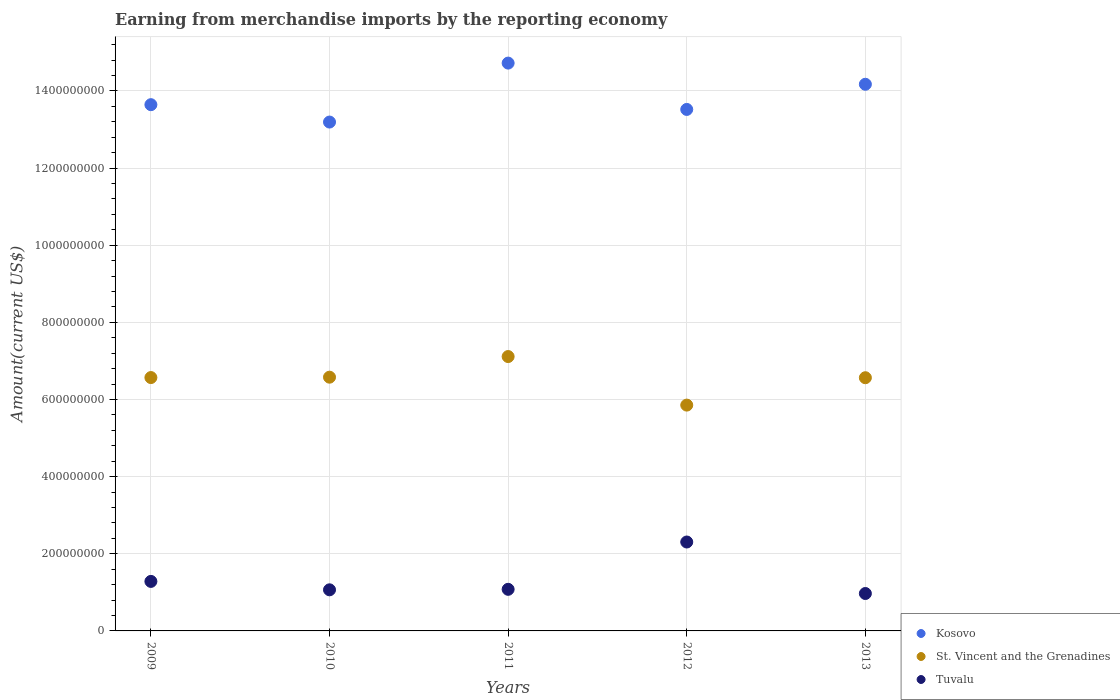What is the amount earned from merchandise imports in St. Vincent and the Grenadines in 2009?
Keep it short and to the point. 6.57e+08. Across all years, what is the maximum amount earned from merchandise imports in Tuvalu?
Your response must be concise. 2.31e+08. Across all years, what is the minimum amount earned from merchandise imports in St. Vincent and the Grenadines?
Offer a terse response. 5.85e+08. What is the total amount earned from merchandise imports in St. Vincent and the Grenadines in the graph?
Give a very brief answer. 3.27e+09. What is the difference between the amount earned from merchandise imports in Kosovo in 2010 and that in 2013?
Offer a very short reply. -9.80e+07. What is the difference between the amount earned from merchandise imports in St. Vincent and the Grenadines in 2013 and the amount earned from merchandise imports in Kosovo in 2012?
Make the answer very short. -6.96e+08. What is the average amount earned from merchandise imports in Tuvalu per year?
Give a very brief answer. 1.34e+08. In the year 2012, what is the difference between the amount earned from merchandise imports in Kosovo and amount earned from merchandise imports in Tuvalu?
Provide a short and direct response. 1.12e+09. In how many years, is the amount earned from merchandise imports in Tuvalu greater than 1400000000 US$?
Your answer should be compact. 0. What is the ratio of the amount earned from merchandise imports in Tuvalu in 2009 to that in 2011?
Offer a terse response. 1.19. Is the amount earned from merchandise imports in Kosovo in 2010 less than that in 2011?
Ensure brevity in your answer.  Yes. What is the difference between the highest and the second highest amount earned from merchandise imports in St. Vincent and the Grenadines?
Give a very brief answer. 5.35e+07. What is the difference between the highest and the lowest amount earned from merchandise imports in St. Vincent and the Grenadines?
Your answer should be very brief. 1.26e+08. In how many years, is the amount earned from merchandise imports in Kosovo greater than the average amount earned from merchandise imports in Kosovo taken over all years?
Provide a succinct answer. 2. Is the amount earned from merchandise imports in St. Vincent and the Grenadines strictly greater than the amount earned from merchandise imports in Tuvalu over the years?
Ensure brevity in your answer.  Yes. Is the amount earned from merchandise imports in Kosovo strictly less than the amount earned from merchandise imports in Tuvalu over the years?
Your answer should be very brief. No. How many dotlines are there?
Your answer should be very brief. 3. What is the difference between two consecutive major ticks on the Y-axis?
Your answer should be compact. 2.00e+08. Are the values on the major ticks of Y-axis written in scientific E-notation?
Offer a very short reply. No. Where does the legend appear in the graph?
Provide a short and direct response. Bottom right. How many legend labels are there?
Provide a short and direct response. 3. How are the legend labels stacked?
Your answer should be very brief. Vertical. What is the title of the graph?
Keep it short and to the point. Earning from merchandise imports by the reporting economy. What is the label or title of the X-axis?
Provide a succinct answer. Years. What is the label or title of the Y-axis?
Provide a short and direct response. Amount(current US$). What is the Amount(current US$) in Kosovo in 2009?
Provide a short and direct response. 1.36e+09. What is the Amount(current US$) in St. Vincent and the Grenadines in 2009?
Your answer should be compact. 6.57e+08. What is the Amount(current US$) in Tuvalu in 2009?
Ensure brevity in your answer.  1.28e+08. What is the Amount(current US$) in Kosovo in 2010?
Your answer should be very brief. 1.32e+09. What is the Amount(current US$) in St. Vincent and the Grenadines in 2010?
Your answer should be very brief. 6.58e+08. What is the Amount(current US$) in Tuvalu in 2010?
Your response must be concise. 1.07e+08. What is the Amount(current US$) in Kosovo in 2011?
Offer a very short reply. 1.47e+09. What is the Amount(current US$) of St. Vincent and the Grenadines in 2011?
Make the answer very short. 7.11e+08. What is the Amount(current US$) in Tuvalu in 2011?
Your answer should be compact. 1.08e+08. What is the Amount(current US$) of Kosovo in 2012?
Keep it short and to the point. 1.35e+09. What is the Amount(current US$) in St. Vincent and the Grenadines in 2012?
Your answer should be compact. 5.85e+08. What is the Amount(current US$) in Tuvalu in 2012?
Ensure brevity in your answer.  2.31e+08. What is the Amount(current US$) in Kosovo in 2013?
Offer a terse response. 1.42e+09. What is the Amount(current US$) in St. Vincent and the Grenadines in 2013?
Provide a short and direct response. 6.56e+08. What is the Amount(current US$) in Tuvalu in 2013?
Offer a terse response. 9.70e+07. Across all years, what is the maximum Amount(current US$) of Kosovo?
Your answer should be very brief. 1.47e+09. Across all years, what is the maximum Amount(current US$) in St. Vincent and the Grenadines?
Offer a terse response. 7.11e+08. Across all years, what is the maximum Amount(current US$) of Tuvalu?
Ensure brevity in your answer.  2.31e+08. Across all years, what is the minimum Amount(current US$) of Kosovo?
Provide a short and direct response. 1.32e+09. Across all years, what is the minimum Amount(current US$) in St. Vincent and the Grenadines?
Your answer should be compact. 5.85e+08. Across all years, what is the minimum Amount(current US$) of Tuvalu?
Offer a very short reply. 9.70e+07. What is the total Amount(current US$) of Kosovo in the graph?
Give a very brief answer. 6.92e+09. What is the total Amount(current US$) of St. Vincent and the Grenadines in the graph?
Ensure brevity in your answer.  3.27e+09. What is the total Amount(current US$) in Tuvalu in the graph?
Offer a very short reply. 6.70e+08. What is the difference between the Amount(current US$) in Kosovo in 2009 and that in 2010?
Your answer should be compact. 4.51e+07. What is the difference between the Amount(current US$) of St. Vincent and the Grenadines in 2009 and that in 2010?
Your answer should be very brief. -9.77e+05. What is the difference between the Amount(current US$) of Tuvalu in 2009 and that in 2010?
Make the answer very short. 2.18e+07. What is the difference between the Amount(current US$) of Kosovo in 2009 and that in 2011?
Offer a terse response. -1.08e+08. What is the difference between the Amount(current US$) of St. Vincent and the Grenadines in 2009 and that in 2011?
Your answer should be very brief. -5.45e+07. What is the difference between the Amount(current US$) of Tuvalu in 2009 and that in 2011?
Ensure brevity in your answer.  2.05e+07. What is the difference between the Amount(current US$) of Kosovo in 2009 and that in 2012?
Your response must be concise. 1.23e+07. What is the difference between the Amount(current US$) of St. Vincent and the Grenadines in 2009 and that in 2012?
Your answer should be very brief. 7.14e+07. What is the difference between the Amount(current US$) of Tuvalu in 2009 and that in 2012?
Offer a terse response. -1.02e+08. What is the difference between the Amount(current US$) of Kosovo in 2009 and that in 2013?
Provide a short and direct response. -5.29e+07. What is the difference between the Amount(current US$) in St. Vincent and the Grenadines in 2009 and that in 2013?
Your response must be concise. 4.21e+05. What is the difference between the Amount(current US$) of Tuvalu in 2009 and that in 2013?
Your answer should be compact. 3.14e+07. What is the difference between the Amount(current US$) of Kosovo in 2010 and that in 2011?
Your response must be concise. -1.53e+08. What is the difference between the Amount(current US$) of St. Vincent and the Grenadines in 2010 and that in 2011?
Ensure brevity in your answer.  -5.35e+07. What is the difference between the Amount(current US$) of Tuvalu in 2010 and that in 2011?
Offer a terse response. -1.28e+06. What is the difference between the Amount(current US$) in Kosovo in 2010 and that in 2012?
Your answer should be compact. -3.27e+07. What is the difference between the Amount(current US$) in St. Vincent and the Grenadines in 2010 and that in 2012?
Give a very brief answer. 7.24e+07. What is the difference between the Amount(current US$) in Tuvalu in 2010 and that in 2012?
Your answer should be compact. -1.24e+08. What is the difference between the Amount(current US$) in Kosovo in 2010 and that in 2013?
Offer a terse response. -9.80e+07. What is the difference between the Amount(current US$) of St. Vincent and the Grenadines in 2010 and that in 2013?
Ensure brevity in your answer.  1.40e+06. What is the difference between the Amount(current US$) in Tuvalu in 2010 and that in 2013?
Your response must be concise. 9.57e+06. What is the difference between the Amount(current US$) in Kosovo in 2011 and that in 2012?
Offer a very short reply. 1.20e+08. What is the difference between the Amount(current US$) of St. Vincent and the Grenadines in 2011 and that in 2012?
Ensure brevity in your answer.  1.26e+08. What is the difference between the Amount(current US$) in Tuvalu in 2011 and that in 2012?
Provide a succinct answer. -1.23e+08. What is the difference between the Amount(current US$) of Kosovo in 2011 and that in 2013?
Give a very brief answer. 5.49e+07. What is the difference between the Amount(current US$) in St. Vincent and the Grenadines in 2011 and that in 2013?
Make the answer very short. 5.49e+07. What is the difference between the Amount(current US$) of Tuvalu in 2011 and that in 2013?
Ensure brevity in your answer.  1.08e+07. What is the difference between the Amount(current US$) in Kosovo in 2012 and that in 2013?
Your answer should be compact. -6.52e+07. What is the difference between the Amount(current US$) in St. Vincent and the Grenadines in 2012 and that in 2013?
Provide a short and direct response. -7.10e+07. What is the difference between the Amount(current US$) of Tuvalu in 2012 and that in 2013?
Your response must be concise. 1.34e+08. What is the difference between the Amount(current US$) in Kosovo in 2009 and the Amount(current US$) in St. Vincent and the Grenadines in 2010?
Make the answer very short. 7.06e+08. What is the difference between the Amount(current US$) of Kosovo in 2009 and the Amount(current US$) of Tuvalu in 2010?
Offer a very short reply. 1.26e+09. What is the difference between the Amount(current US$) in St. Vincent and the Grenadines in 2009 and the Amount(current US$) in Tuvalu in 2010?
Offer a very short reply. 5.50e+08. What is the difference between the Amount(current US$) of Kosovo in 2009 and the Amount(current US$) of St. Vincent and the Grenadines in 2011?
Ensure brevity in your answer.  6.53e+08. What is the difference between the Amount(current US$) of Kosovo in 2009 and the Amount(current US$) of Tuvalu in 2011?
Provide a short and direct response. 1.26e+09. What is the difference between the Amount(current US$) in St. Vincent and the Grenadines in 2009 and the Amount(current US$) in Tuvalu in 2011?
Give a very brief answer. 5.49e+08. What is the difference between the Amount(current US$) in Kosovo in 2009 and the Amount(current US$) in St. Vincent and the Grenadines in 2012?
Ensure brevity in your answer.  7.79e+08. What is the difference between the Amount(current US$) in Kosovo in 2009 and the Amount(current US$) in Tuvalu in 2012?
Provide a succinct answer. 1.13e+09. What is the difference between the Amount(current US$) of St. Vincent and the Grenadines in 2009 and the Amount(current US$) of Tuvalu in 2012?
Your response must be concise. 4.26e+08. What is the difference between the Amount(current US$) of Kosovo in 2009 and the Amount(current US$) of St. Vincent and the Grenadines in 2013?
Offer a very short reply. 7.08e+08. What is the difference between the Amount(current US$) of Kosovo in 2009 and the Amount(current US$) of Tuvalu in 2013?
Provide a short and direct response. 1.27e+09. What is the difference between the Amount(current US$) of St. Vincent and the Grenadines in 2009 and the Amount(current US$) of Tuvalu in 2013?
Ensure brevity in your answer.  5.60e+08. What is the difference between the Amount(current US$) of Kosovo in 2010 and the Amount(current US$) of St. Vincent and the Grenadines in 2011?
Your answer should be compact. 6.08e+08. What is the difference between the Amount(current US$) of Kosovo in 2010 and the Amount(current US$) of Tuvalu in 2011?
Provide a succinct answer. 1.21e+09. What is the difference between the Amount(current US$) of St. Vincent and the Grenadines in 2010 and the Amount(current US$) of Tuvalu in 2011?
Keep it short and to the point. 5.50e+08. What is the difference between the Amount(current US$) in Kosovo in 2010 and the Amount(current US$) in St. Vincent and the Grenadines in 2012?
Make the answer very short. 7.34e+08. What is the difference between the Amount(current US$) of Kosovo in 2010 and the Amount(current US$) of Tuvalu in 2012?
Give a very brief answer. 1.09e+09. What is the difference between the Amount(current US$) of St. Vincent and the Grenadines in 2010 and the Amount(current US$) of Tuvalu in 2012?
Make the answer very short. 4.27e+08. What is the difference between the Amount(current US$) of Kosovo in 2010 and the Amount(current US$) of St. Vincent and the Grenadines in 2013?
Your response must be concise. 6.63e+08. What is the difference between the Amount(current US$) in Kosovo in 2010 and the Amount(current US$) in Tuvalu in 2013?
Ensure brevity in your answer.  1.22e+09. What is the difference between the Amount(current US$) in St. Vincent and the Grenadines in 2010 and the Amount(current US$) in Tuvalu in 2013?
Your answer should be compact. 5.61e+08. What is the difference between the Amount(current US$) in Kosovo in 2011 and the Amount(current US$) in St. Vincent and the Grenadines in 2012?
Your response must be concise. 8.87e+08. What is the difference between the Amount(current US$) in Kosovo in 2011 and the Amount(current US$) in Tuvalu in 2012?
Give a very brief answer. 1.24e+09. What is the difference between the Amount(current US$) of St. Vincent and the Grenadines in 2011 and the Amount(current US$) of Tuvalu in 2012?
Offer a very short reply. 4.81e+08. What is the difference between the Amount(current US$) in Kosovo in 2011 and the Amount(current US$) in St. Vincent and the Grenadines in 2013?
Keep it short and to the point. 8.16e+08. What is the difference between the Amount(current US$) in Kosovo in 2011 and the Amount(current US$) in Tuvalu in 2013?
Your answer should be very brief. 1.38e+09. What is the difference between the Amount(current US$) of St. Vincent and the Grenadines in 2011 and the Amount(current US$) of Tuvalu in 2013?
Your response must be concise. 6.14e+08. What is the difference between the Amount(current US$) in Kosovo in 2012 and the Amount(current US$) in St. Vincent and the Grenadines in 2013?
Offer a very short reply. 6.96e+08. What is the difference between the Amount(current US$) of Kosovo in 2012 and the Amount(current US$) of Tuvalu in 2013?
Offer a very short reply. 1.26e+09. What is the difference between the Amount(current US$) of St. Vincent and the Grenadines in 2012 and the Amount(current US$) of Tuvalu in 2013?
Ensure brevity in your answer.  4.88e+08. What is the average Amount(current US$) in Kosovo per year?
Offer a terse response. 1.38e+09. What is the average Amount(current US$) in St. Vincent and the Grenadines per year?
Offer a very short reply. 6.54e+08. What is the average Amount(current US$) of Tuvalu per year?
Your answer should be compact. 1.34e+08. In the year 2009, what is the difference between the Amount(current US$) in Kosovo and Amount(current US$) in St. Vincent and the Grenadines?
Ensure brevity in your answer.  7.07e+08. In the year 2009, what is the difference between the Amount(current US$) of Kosovo and Amount(current US$) of Tuvalu?
Ensure brevity in your answer.  1.24e+09. In the year 2009, what is the difference between the Amount(current US$) of St. Vincent and the Grenadines and Amount(current US$) of Tuvalu?
Keep it short and to the point. 5.28e+08. In the year 2010, what is the difference between the Amount(current US$) in Kosovo and Amount(current US$) in St. Vincent and the Grenadines?
Ensure brevity in your answer.  6.61e+08. In the year 2010, what is the difference between the Amount(current US$) in Kosovo and Amount(current US$) in Tuvalu?
Give a very brief answer. 1.21e+09. In the year 2010, what is the difference between the Amount(current US$) of St. Vincent and the Grenadines and Amount(current US$) of Tuvalu?
Your response must be concise. 5.51e+08. In the year 2011, what is the difference between the Amount(current US$) of Kosovo and Amount(current US$) of St. Vincent and the Grenadines?
Keep it short and to the point. 7.61e+08. In the year 2011, what is the difference between the Amount(current US$) in Kosovo and Amount(current US$) in Tuvalu?
Offer a very short reply. 1.36e+09. In the year 2011, what is the difference between the Amount(current US$) of St. Vincent and the Grenadines and Amount(current US$) of Tuvalu?
Provide a succinct answer. 6.03e+08. In the year 2012, what is the difference between the Amount(current US$) in Kosovo and Amount(current US$) in St. Vincent and the Grenadines?
Your answer should be very brief. 7.67e+08. In the year 2012, what is the difference between the Amount(current US$) in Kosovo and Amount(current US$) in Tuvalu?
Your answer should be compact. 1.12e+09. In the year 2012, what is the difference between the Amount(current US$) in St. Vincent and the Grenadines and Amount(current US$) in Tuvalu?
Offer a very short reply. 3.55e+08. In the year 2013, what is the difference between the Amount(current US$) of Kosovo and Amount(current US$) of St. Vincent and the Grenadines?
Keep it short and to the point. 7.61e+08. In the year 2013, what is the difference between the Amount(current US$) in Kosovo and Amount(current US$) in Tuvalu?
Your answer should be very brief. 1.32e+09. In the year 2013, what is the difference between the Amount(current US$) of St. Vincent and the Grenadines and Amount(current US$) of Tuvalu?
Your response must be concise. 5.59e+08. What is the ratio of the Amount(current US$) in Kosovo in 2009 to that in 2010?
Provide a short and direct response. 1.03. What is the ratio of the Amount(current US$) of Tuvalu in 2009 to that in 2010?
Provide a short and direct response. 1.2. What is the ratio of the Amount(current US$) in Kosovo in 2009 to that in 2011?
Your answer should be compact. 0.93. What is the ratio of the Amount(current US$) in St. Vincent and the Grenadines in 2009 to that in 2011?
Your response must be concise. 0.92. What is the ratio of the Amount(current US$) of Tuvalu in 2009 to that in 2011?
Give a very brief answer. 1.19. What is the ratio of the Amount(current US$) of Kosovo in 2009 to that in 2012?
Your response must be concise. 1.01. What is the ratio of the Amount(current US$) in St. Vincent and the Grenadines in 2009 to that in 2012?
Offer a very short reply. 1.12. What is the ratio of the Amount(current US$) of Tuvalu in 2009 to that in 2012?
Provide a short and direct response. 0.56. What is the ratio of the Amount(current US$) in Kosovo in 2009 to that in 2013?
Give a very brief answer. 0.96. What is the ratio of the Amount(current US$) in Tuvalu in 2009 to that in 2013?
Give a very brief answer. 1.32. What is the ratio of the Amount(current US$) of Kosovo in 2010 to that in 2011?
Offer a very short reply. 0.9. What is the ratio of the Amount(current US$) of St. Vincent and the Grenadines in 2010 to that in 2011?
Ensure brevity in your answer.  0.92. What is the ratio of the Amount(current US$) of Tuvalu in 2010 to that in 2011?
Offer a terse response. 0.99. What is the ratio of the Amount(current US$) in Kosovo in 2010 to that in 2012?
Your answer should be very brief. 0.98. What is the ratio of the Amount(current US$) in St. Vincent and the Grenadines in 2010 to that in 2012?
Provide a short and direct response. 1.12. What is the ratio of the Amount(current US$) of Tuvalu in 2010 to that in 2012?
Keep it short and to the point. 0.46. What is the ratio of the Amount(current US$) in Kosovo in 2010 to that in 2013?
Provide a short and direct response. 0.93. What is the ratio of the Amount(current US$) in Tuvalu in 2010 to that in 2013?
Offer a very short reply. 1.1. What is the ratio of the Amount(current US$) of Kosovo in 2011 to that in 2012?
Your response must be concise. 1.09. What is the ratio of the Amount(current US$) in St. Vincent and the Grenadines in 2011 to that in 2012?
Offer a terse response. 1.22. What is the ratio of the Amount(current US$) in Tuvalu in 2011 to that in 2012?
Offer a terse response. 0.47. What is the ratio of the Amount(current US$) in Kosovo in 2011 to that in 2013?
Provide a succinct answer. 1.04. What is the ratio of the Amount(current US$) of St. Vincent and the Grenadines in 2011 to that in 2013?
Your answer should be compact. 1.08. What is the ratio of the Amount(current US$) in Tuvalu in 2011 to that in 2013?
Your response must be concise. 1.11. What is the ratio of the Amount(current US$) in Kosovo in 2012 to that in 2013?
Your answer should be compact. 0.95. What is the ratio of the Amount(current US$) of St. Vincent and the Grenadines in 2012 to that in 2013?
Your answer should be very brief. 0.89. What is the ratio of the Amount(current US$) of Tuvalu in 2012 to that in 2013?
Make the answer very short. 2.38. What is the difference between the highest and the second highest Amount(current US$) of Kosovo?
Offer a terse response. 5.49e+07. What is the difference between the highest and the second highest Amount(current US$) of St. Vincent and the Grenadines?
Ensure brevity in your answer.  5.35e+07. What is the difference between the highest and the second highest Amount(current US$) in Tuvalu?
Ensure brevity in your answer.  1.02e+08. What is the difference between the highest and the lowest Amount(current US$) in Kosovo?
Offer a very short reply. 1.53e+08. What is the difference between the highest and the lowest Amount(current US$) of St. Vincent and the Grenadines?
Offer a terse response. 1.26e+08. What is the difference between the highest and the lowest Amount(current US$) in Tuvalu?
Give a very brief answer. 1.34e+08. 